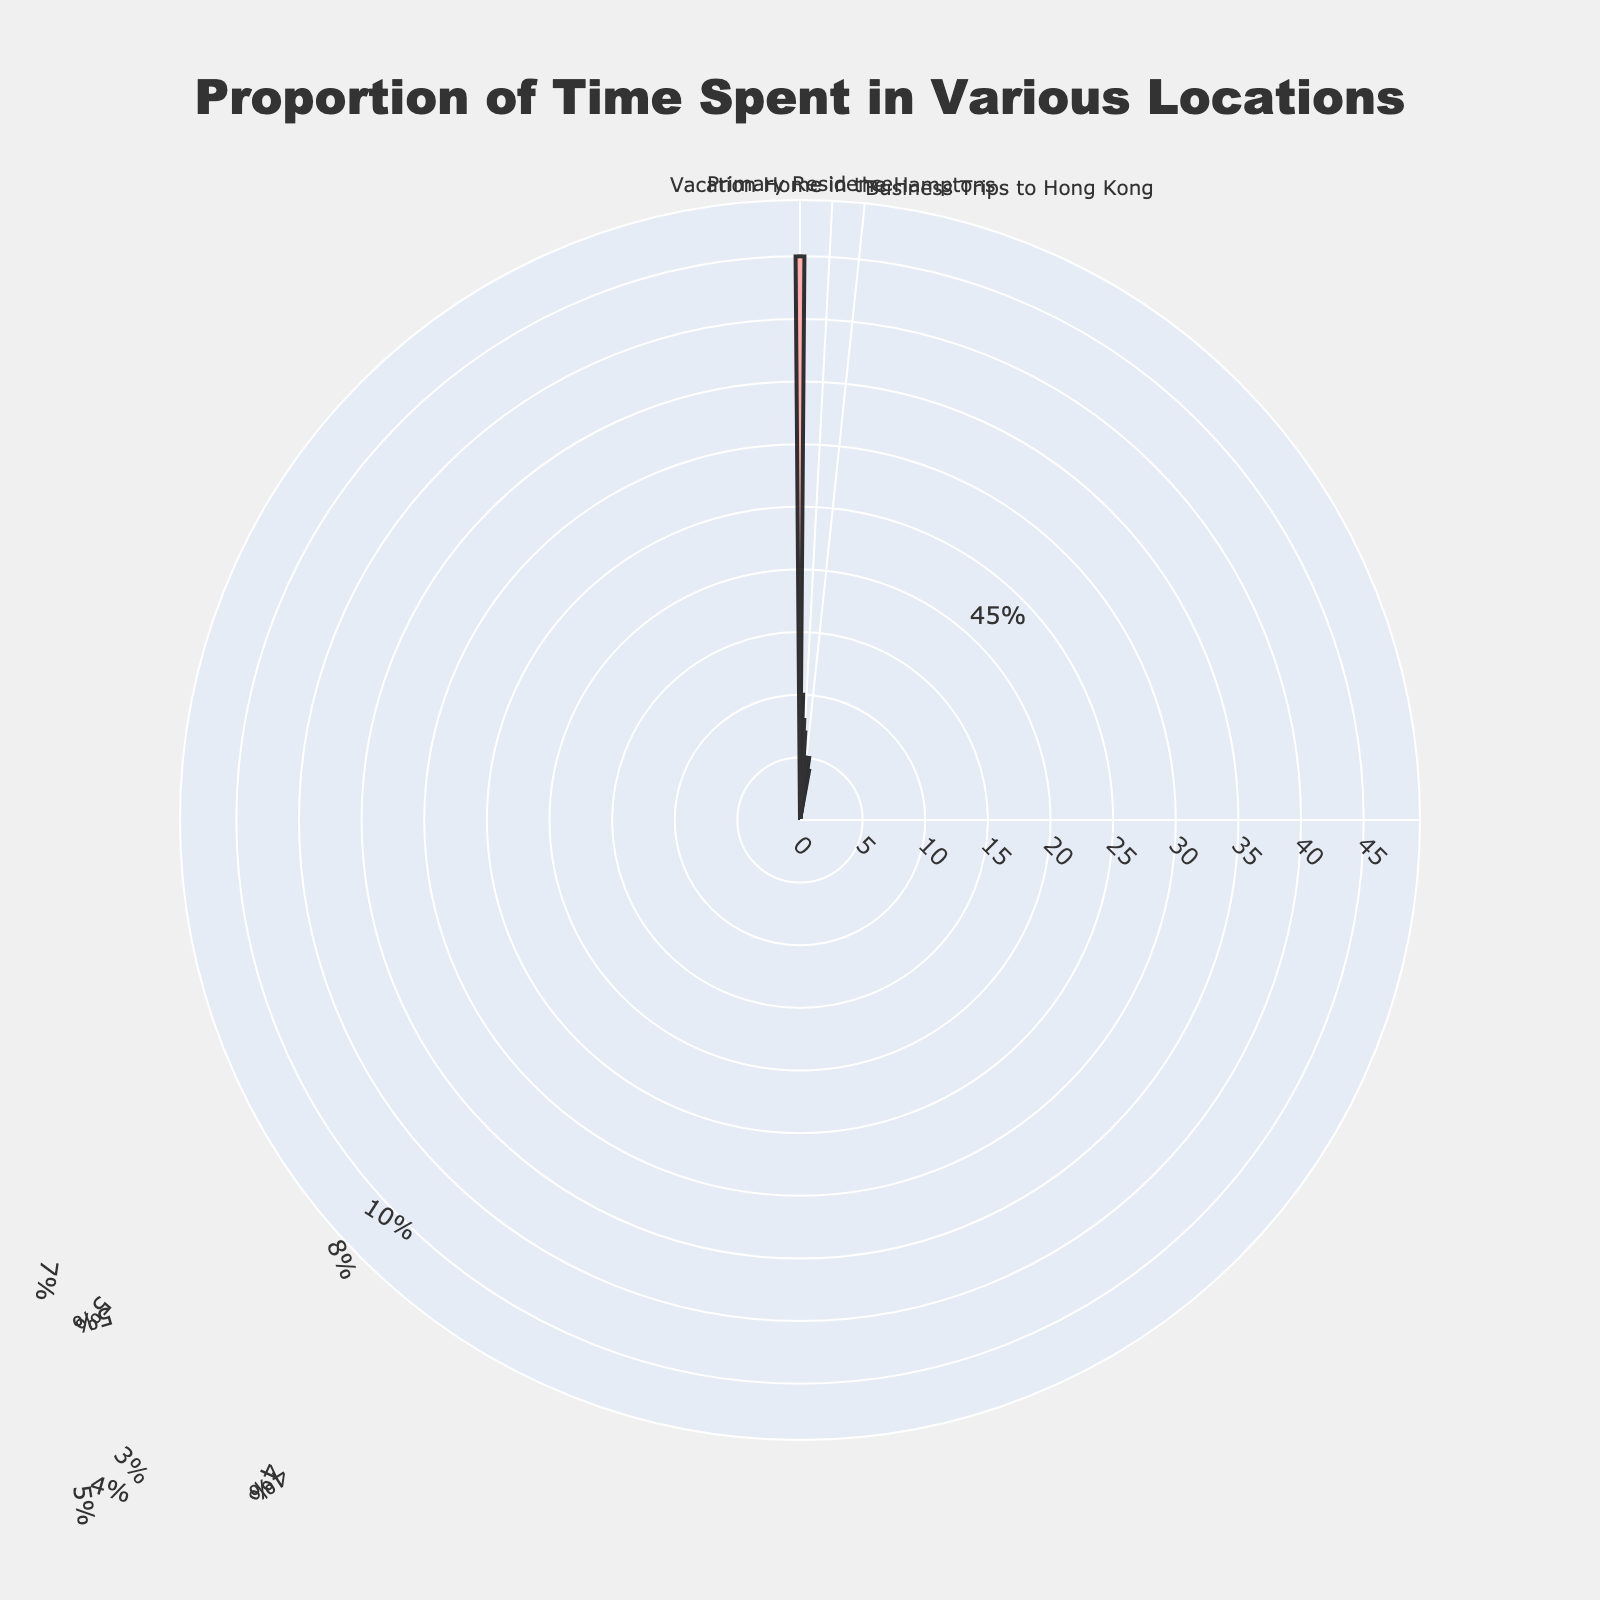What is the title of the chart? The title is located at the top of the visual representation of the data. It provides a quick summary of what the chart is about.
Answer: Proportion of Time Spent in Various Locations Which location did I spend the most time in? You can identify this by looking for the largest segment in the polar chart, which represents the highest percentage.
Answer: Primary Residence What is the total percentage of time spent in all vacation homes combined? Add the percentages of time spent in each vacation home: St. Barts (10%), Aspen (8%), and the Hamptons (7%). Calculation: 10 + 8 + 7.
Answer: 25% How does the time spent on business trips to New York compare to the time spent on business trips to Dubai? Compare the percentages of time spent on business trips to these two locations. New York (5%) and Dubai (3%).
Answer: New York is 2% higher Which social event location had the lowest percentage of time spent? Identify the segment representing social events with the smallest percentage. There are social events in Los Angeles (5%), Paris (4%), and Miami (4%).
Answer: Paris and Miami What is the total percentage of time spent on business trips? Add the percentages of time spent on business trips to New York (5%), London (5%), Hong Kong (4%), and Dubai (3%). Calculation: 5 + 5 + 4 + 3.
Answer: 17% How much more time is spent at the primary residence compared to vacation homes in Aspen and the Hamptons combined? Calculate the difference between the time spent at the primary residence (45%) and the combined time spent in Aspen (8%) and the Hamptons (7%). Calculation: 45 - (8 + 7).
Answer: 30% What is the combined percentage of time spent at vacation homes and social events? Add the percentages of time spent at all vacation homes and social events. Vacation homes: St. Barts (10%), Aspen (8%), Hamptons (7%). Social events: Los Angeles (5%), Paris (4%), Miami (4%). Calculation: 10 + 8 + 7 + 5 + 4 + 4.
Answer: 38% Which category showed the least variation in the percentage of time spent (vacation homes, business trips, or social events)? Compare the range of percentages within each category. Vacation homes vary from 7% to 10%, business trips from 3% to 5%, and social events at 4% to 5%.
Answer: Social events What is the average percentage of time spent on social events? Calculate the average by adding the percentages of time spent in Los Angeles (5%), Paris (4%), and Miami (4%), then dividing by the number of social event locations. Calculation: (5 + 4 + 4) / 3.
Answer: 4.33% or approximately 4.3% 